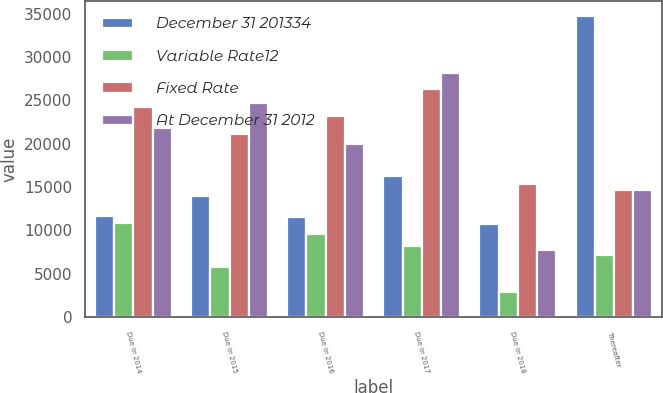Convert chart to OTSL. <chart><loc_0><loc_0><loc_500><loc_500><stacked_bar_chart><ecel><fcel>Due in 2014<fcel>Due in 2015<fcel>Due in 2016<fcel>Due in 2017<fcel>Due in 2018<fcel>Thereafter<nl><fcel>December 31 201334<fcel>11665<fcel>13962<fcel>11521<fcel>16227<fcel>10689<fcel>34748<nl><fcel>Variable Rate12<fcel>10830<fcel>5760<fcel>9621<fcel>8231<fcel>2886<fcel>7165<nl><fcel>Fixed Rate<fcel>24193<fcel>21090<fcel>23144<fcel>26295<fcel>15308<fcel>14635<nl><fcel>At December 31 2012<fcel>21751<fcel>24653<fcel>19984<fcel>28137<fcel>7733<fcel>14635<nl></chart> 